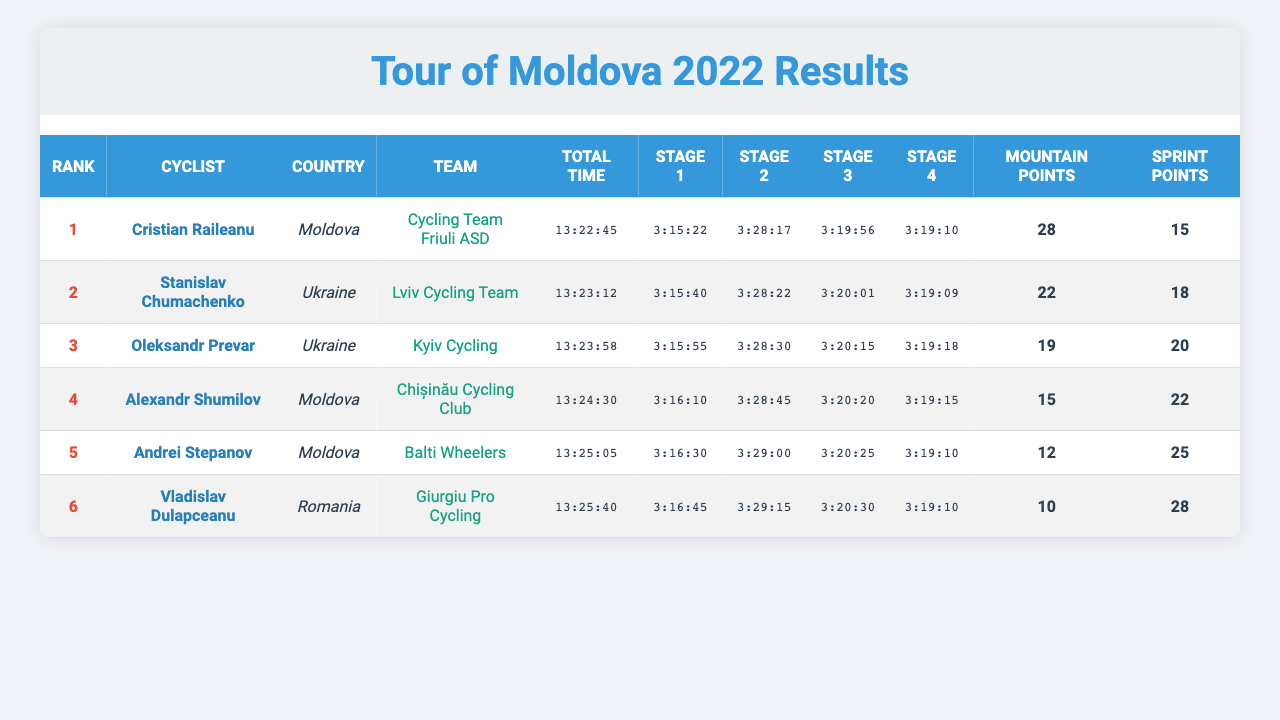What is the total time taken by Cristian Raileanu? The total time for Cristian Raileanu, as listed in the table, is 13:22:45.
Answer: 13:22:45 Which cyclist earned the most mountain points? Cristian Raileanu earned the most mountain points at 28.
Answer: Cristian Raileanu What was the overall ranking of Alexandr Shumilov? Alexandr Shumilov is ranked 4th overall according to the table.
Answer: 4 How many total sprint points did Oleksandr Prevar score? Oleksandr Prevar scored a total of 20 sprint points, as indicated in the table.
Answer: 20 What was the difference in total time between the second and third ranked cyclists? The second-ranked cyclist, Stanislav Chumachenko, had a total time of 13:23:12, and Oleksandr Prevar (third) had 13:23:58. The difference is 46 seconds.
Answer: 46 seconds Did any cyclist from Romania score more sprint points than Andrei Stepanov? Yes, Vladislav Dulapceanu scored 28 sprint points, which is more than Andrei Stepanov's 25 points.
Answer: Yes What is the average total time of the top five cyclists? The total time for the top five cyclists is 13:22:45 + 13:23:12 + 13:23:58 + 13:24:30 + 13:25:05 = 66:59:00 (which is 66 hours, 59 minutes). Dividing this by 5 gives an average of 13:23:48.
Answer: 13:23:48 Who finished fourth and what was their team? Alexandr Shumilov finished fourth and was part of the Chișinău Cycling Club team.
Answer: Alexandr Shumilov, Chișinău Cycling Club Were all the Moldovan cyclists ranked in the top five? No, only Cristian Raileanu, Alexandr Shumilov, and Andrei Stepanov are ranked in the top five.
Answer: No What was the best stage time recorded by Cristian Raileanu in Stage 1? Cristian Raileanu achieved a stage time of 3:15:22 in Stage 1, which is the best stage time recorded by him.
Answer: 3:15:22 